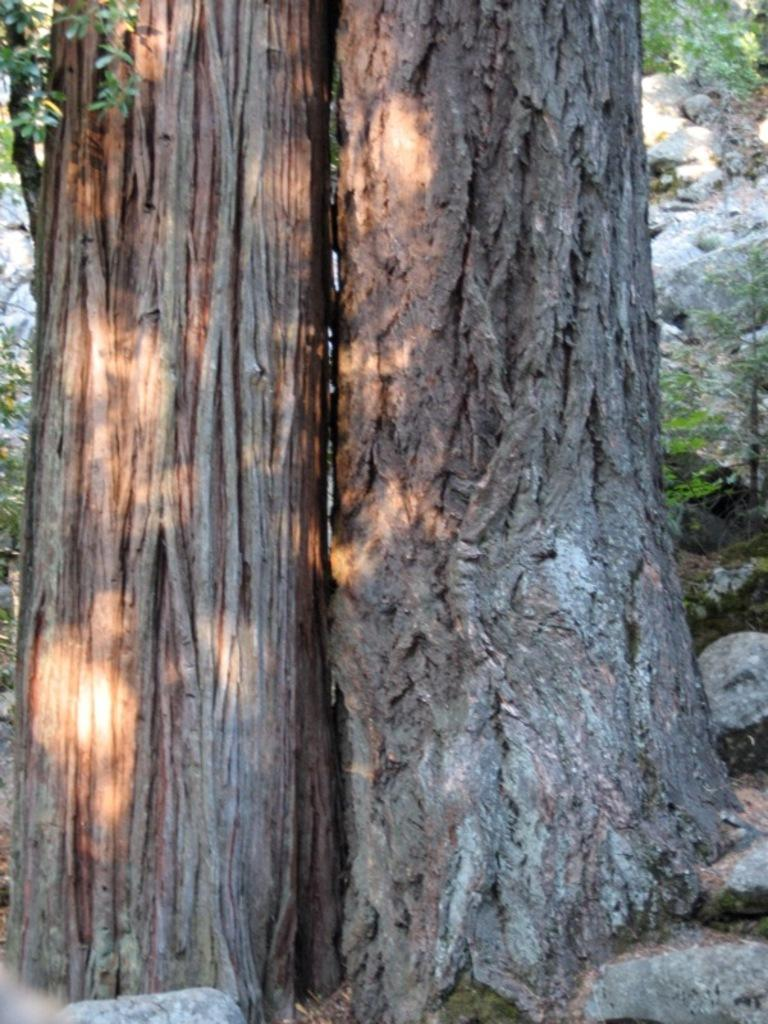What part of the trees can be seen in the image? The bark of trees is visible in the image. What type of natural objects can be found on the ground in the image? There are stones in the image. What type of vegetation is present in the image? Leaves are present in the image. Can you see the thrill of the ants in the image? There are no ants present in the image, so it is not possible to see their thrill. 